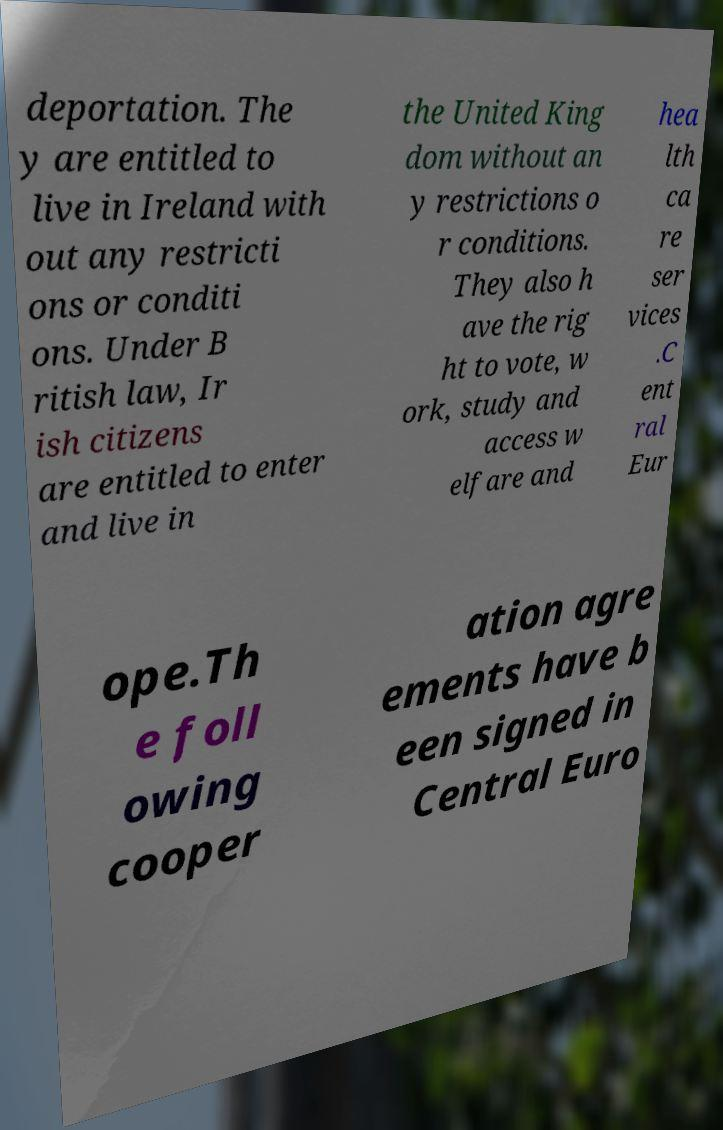What messages or text are displayed in this image? I need them in a readable, typed format. deportation. The y are entitled to live in Ireland with out any restricti ons or conditi ons. Under B ritish law, Ir ish citizens are entitled to enter and live in the United King dom without an y restrictions o r conditions. They also h ave the rig ht to vote, w ork, study and access w elfare and hea lth ca re ser vices .C ent ral Eur ope.Th e foll owing cooper ation agre ements have b een signed in Central Euro 